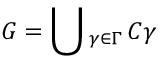Convert formula to latex. <formula><loc_0><loc_0><loc_500><loc_500>G = _ { \gamma \in \Gamma } \, C \gamma</formula> 